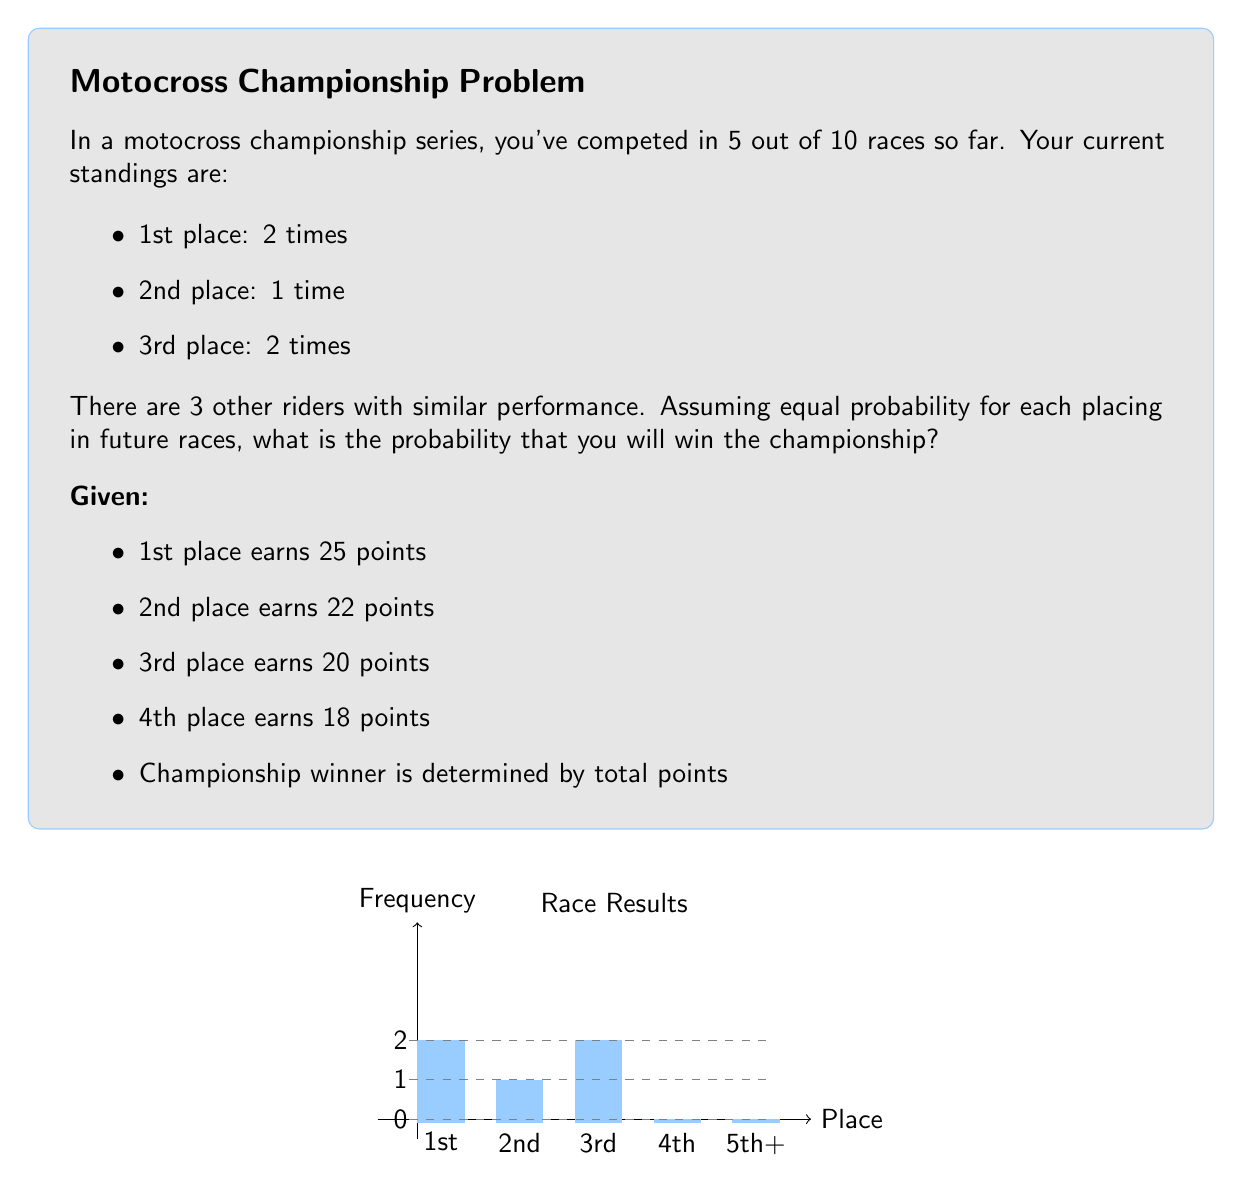Provide a solution to this math problem. Let's approach this step-by-step:

1) First, calculate your current points:
   $$(2 \times 25) + (1 \times 22) + (2 \times 20) = 112$$ points

2) For the remaining 5 races, we need to calculate the expected points:
   Average points per race = $\frac{25 + 22 + 20 + 18}{4} = 21.25$
   Expected additional points = $21.25 \times 5 = 106.25$

3) Total expected points at the end = $112 + 106.25 = 218.25$

4) Now, we need to calculate the probability of each competitor having less than 218.25 points:
   
   Let $X$ be the total points for a competitor.
   $X \sim N(\mu, \sigma^2)$ where:
   $\mu = 10 \times 21.25 = 212.5$
   $\sigma^2 = 10 \times \frac{(25-21.25)^2 + (22-21.25)^2 + (20-21.25)^2 + (18-21.25)^2}{4} = 52.5$

5) Probability of a competitor having less than 218.25 points:
   $$P(X < 218.25) = P(Z < \frac{218.25 - 212.5}{\sqrt{52.5}}) = P(Z < 0.79)$$
   Using a standard normal table, this probability is approximately 0.7852

6) Probability of winning (all 3 competitors having less points):
   $$0.7852^3 \approx 0.4843$$

Therefore, the probability of winning the championship is approximately 0.4843 or 48.43%.
Answer: $0.4843$ or $48.43\%$ 